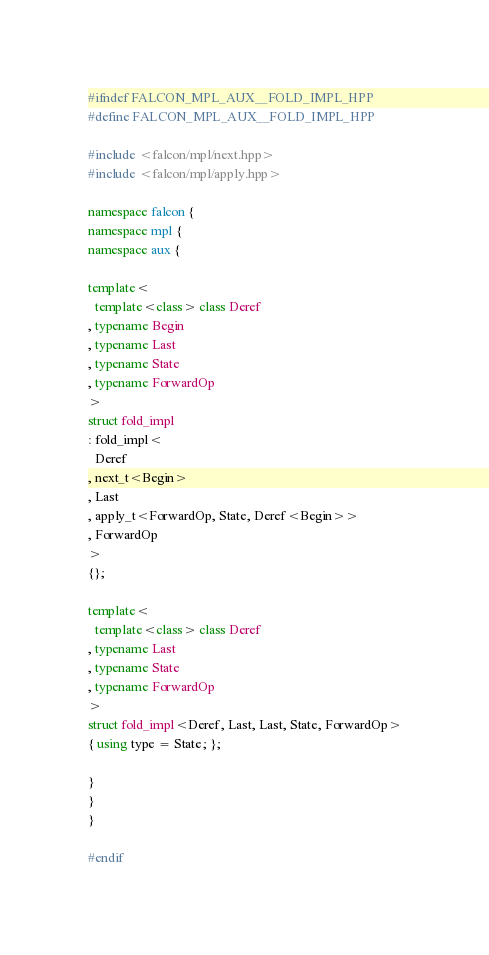<code> <loc_0><loc_0><loc_500><loc_500><_C++_>#ifndef FALCON_MPL_AUX__FOLD_IMPL_HPP
#define FALCON_MPL_AUX__FOLD_IMPL_HPP

#include <falcon/mpl/next.hpp>
#include <falcon/mpl/apply.hpp>

namespace falcon {
namespace mpl {
namespace aux {

template<
  template<class> class Deref
, typename Begin
, typename Last
, typename State
, typename ForwardOp
>
struct fold_impl
: fold_impl<
  Deref
, next_t<Begin>
, Last
, apply_t<ForwardOp, State, Deref<Begin>>
, ForwardOp
>
{};

template<
  template<class> class Deref
, typename Last
, typename State
, typename ForwardOp
>
struct fold_impl<Deref, Last, Last, State, ForwardOp>
{ using type = State; };

}
}
}

#endif
</code> 